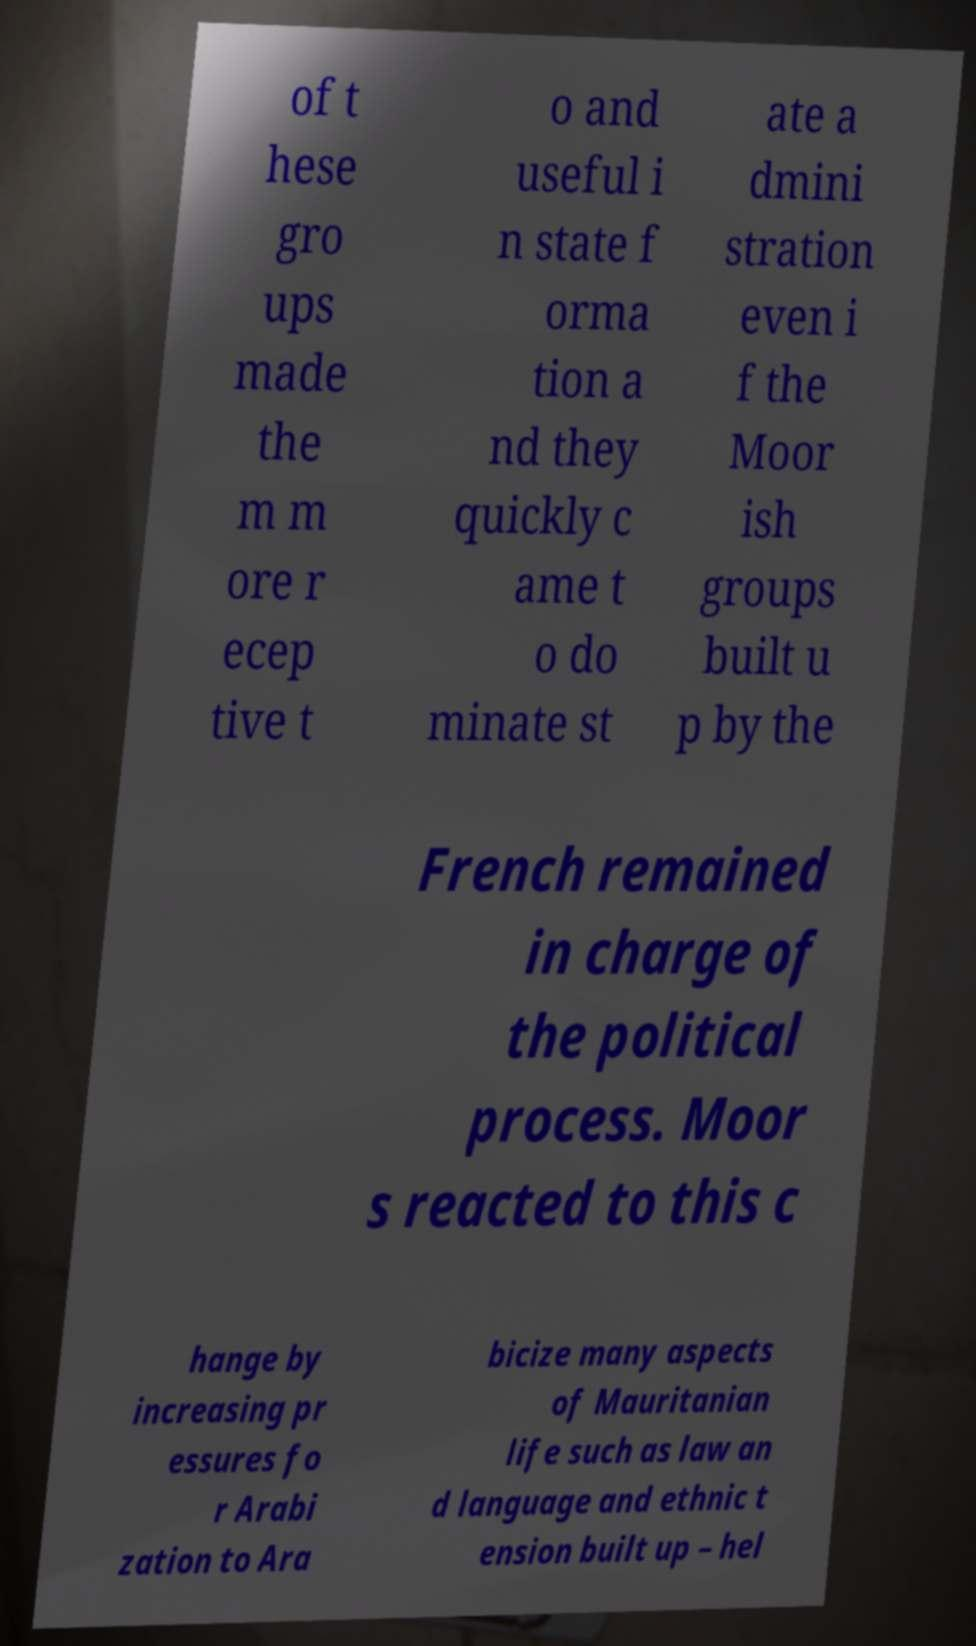For documentation purposes, I need the text within this image transcribed. Could you provide that? of t hese gro ups made the m m ore r ecep tive t o and useful i n state f orma tion a nd they quickly c ame t o do minate st ate a dmini stration even i f the Moor ish groups built u p by the French remained in charge of the political process. Moor s reacted to this c hange by increasing pr essures fo r Arabi zation to Ara bicize many aspects of Mauritanian life such as law an d language and ethnic t ension built up – hel 